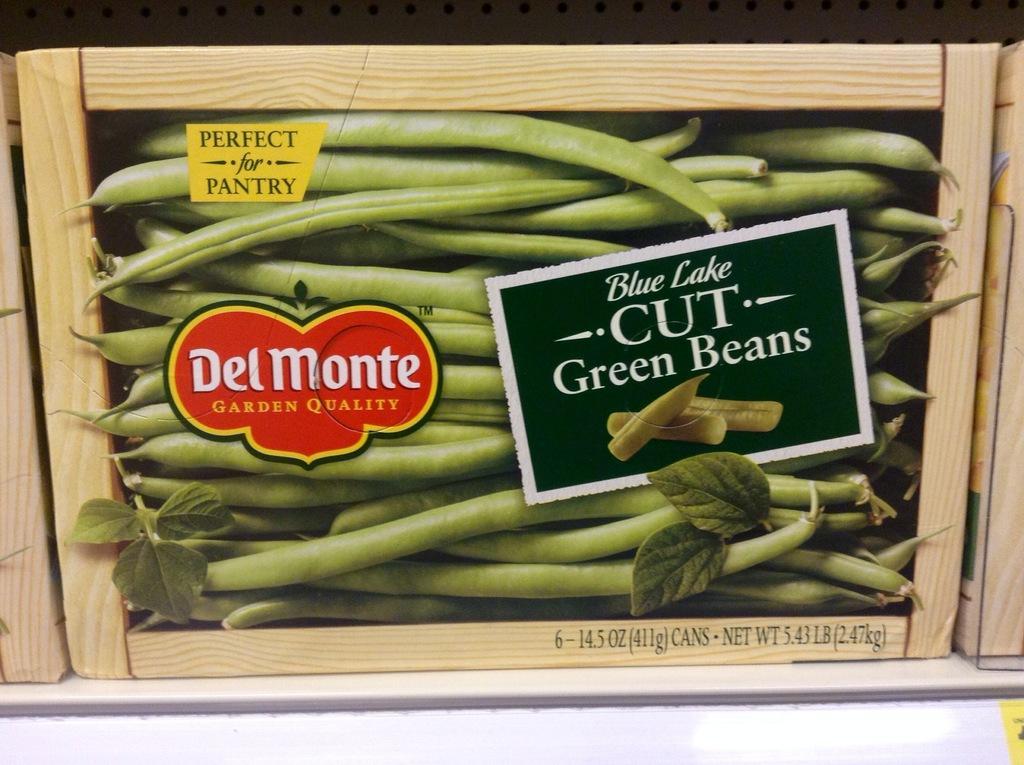Could you give a brief overview of what you see in this image? In this image I see many beans over here and I see the green leaves and I see 3 stickers on which there are words written and I see few words written over here and I see the wooden sticks. 